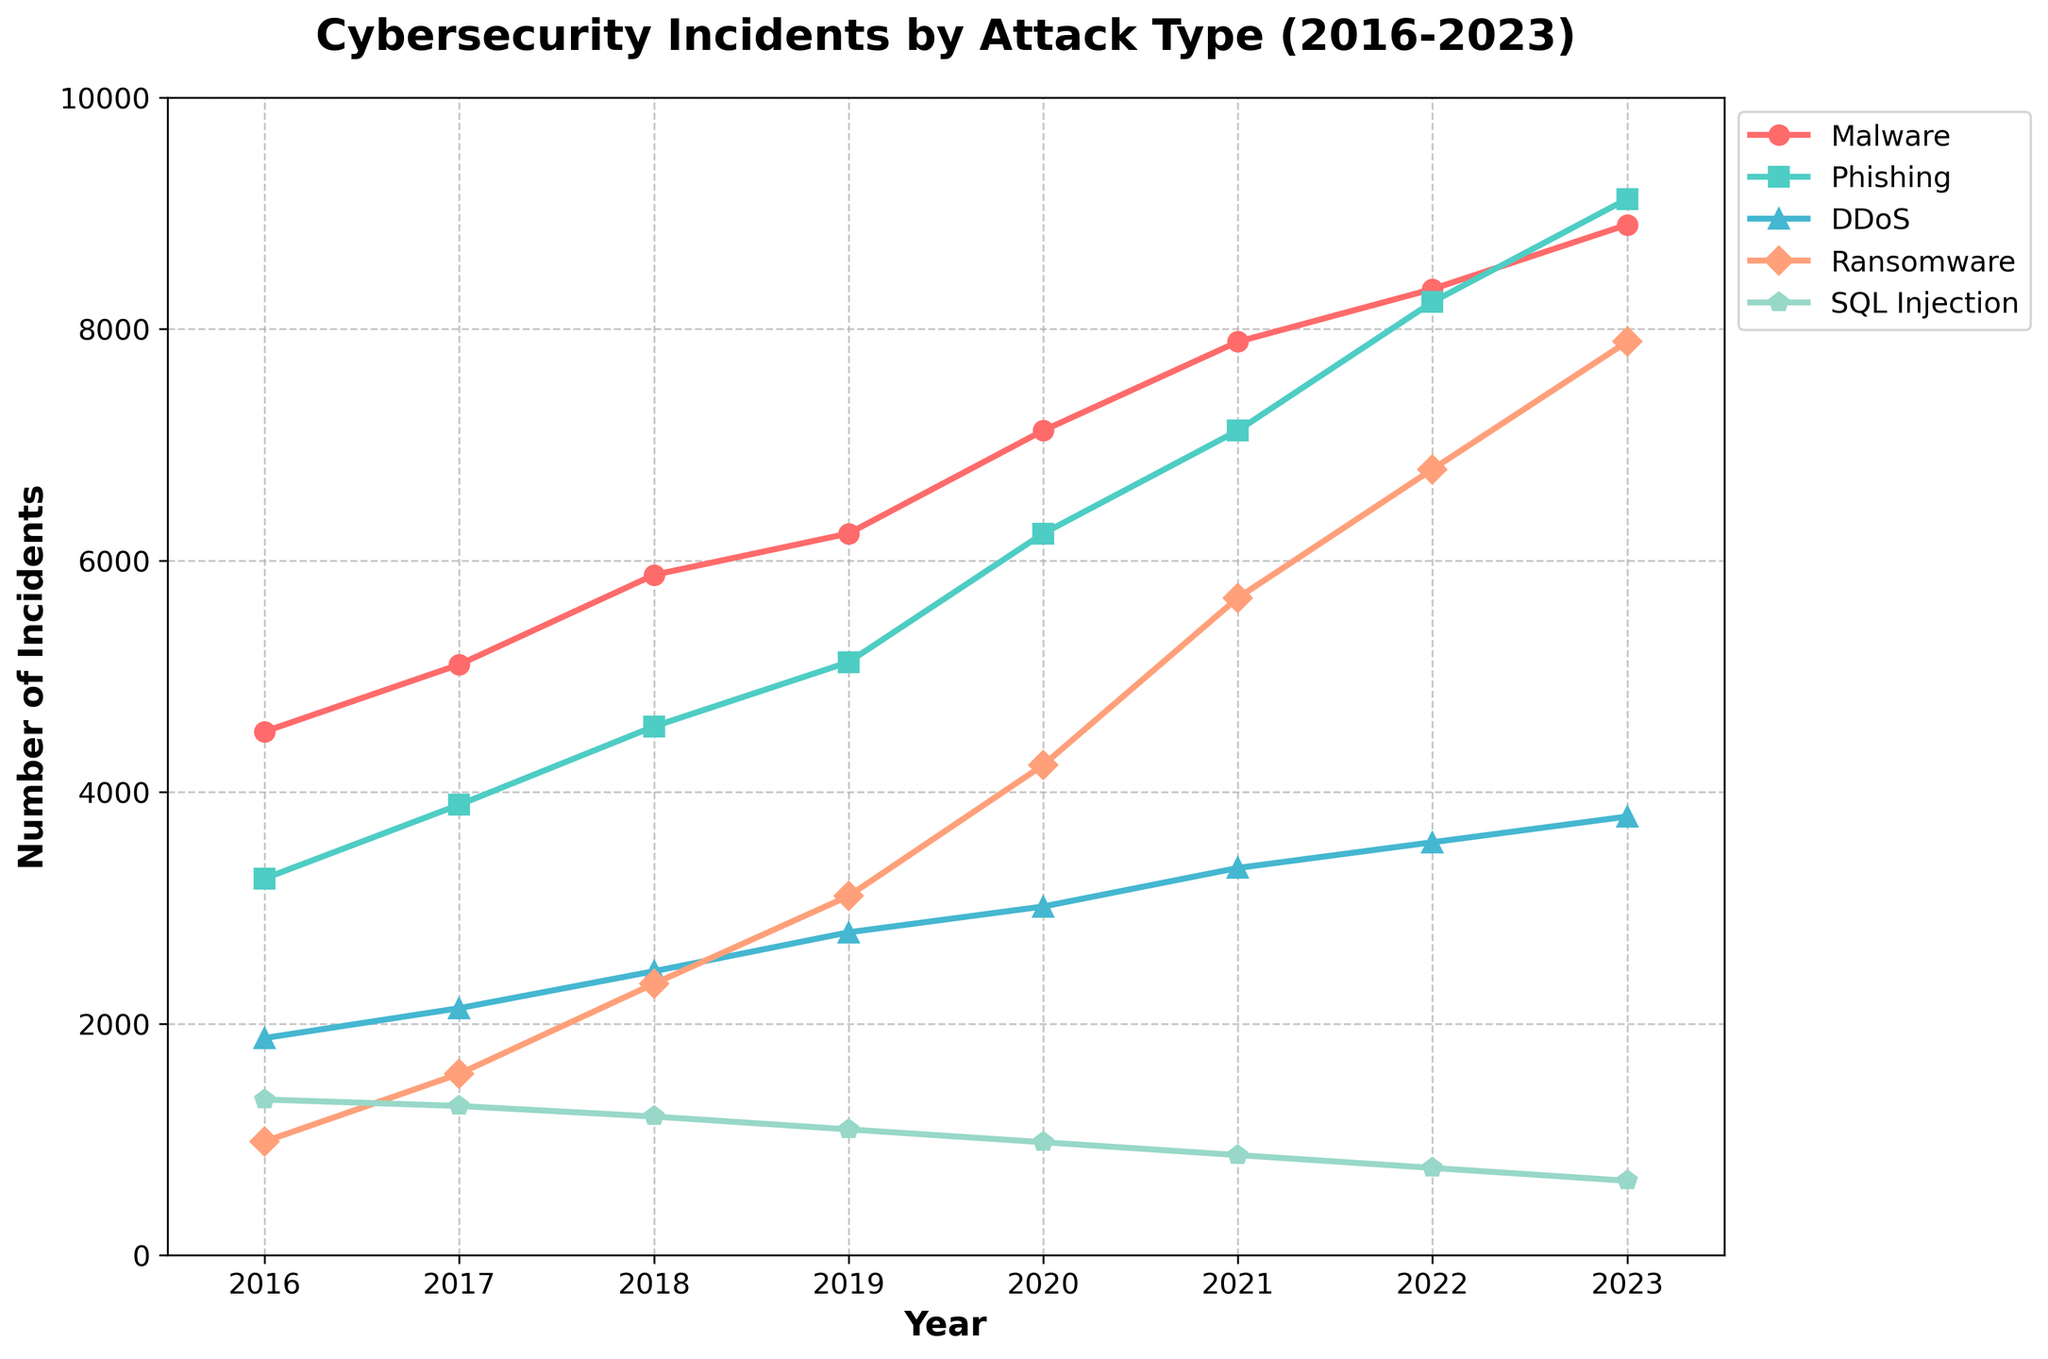Which year had the highest number of Phishing incidents? Looking at the Phishing line (the green line), we see that 2023 had the highest value, around 9123.
Answer: 2023 Which attack type showed the greatest increase in incidents from 2016 to 2023? Calculating the difference for each attack type: Malware (8901 - 4523 = 4378), Phishing (9123 - 3254 = 5869), DDoS (3789 - 1876 = 1913), Ransomware (7890 - 982 = 6908), SQL Injection (643 - 1345 = -702). Ransomware shows the greatest increase.
Answer: Ransomware How did the number of Malware incidents change between 2016 and 2023? The value in 2016 is 4523, and in 2023, it is 8901. The change is 8901 - 4523 = 4378.
Answer: Increased by 4378 Compare the trends for DDoS and SQL Injection incidents over the years. DDoS incidents (blue line) show an increasing trend from 1876 in 2016 to 3789 in 2023. SQL Injection incidents (purple line) decrease from 1345 in 2016 to 643 in 2023.
Answer: DDoS increased, SQL Injection decreased In which year did Ransomware incidents surpass 5000? Following the purple Ransomware line, the value surpasses 5000 in 2020.
Answer: 2020 What is the average number of Phishing incidents from 2016 to 2023? Sum of Phishing incidents = 3254 + 3891 + 4567 + 5123 + 6234 + 7123 + 8234 + 9123 = 47549. There are 8 years, so the average is 47549 / 8 = 5943.625.
Answer: 5943.625 How much higher were DDoS incidents in 2023 compared to 2019? The DDoS value in 2023 is 3789 and in 2019 is 2789. The difference is 3789 - 2789 = 1000.
Answer: 1000 Which attack type experienced a decrease in incidents from 2016 to 2023? Observing the lines, SQL Injection incidents decreased from 1345 in 2016 to 643 in 2023.
Answer: SQL Injection Analyze the relative growth of Ransomware incidents between 2016 and 2023. The initial value in 2016 is 982 and the final value in 2023 is 7890. The relative growth is (7890 / 982) = 8.035, or 803.5%.
Answer: 803.5% What are the visual characteristics that indicate Phishing incidents on the chart? The Phishing incidents are represented by a green line with square markers.
Answer: Green line with square markers 